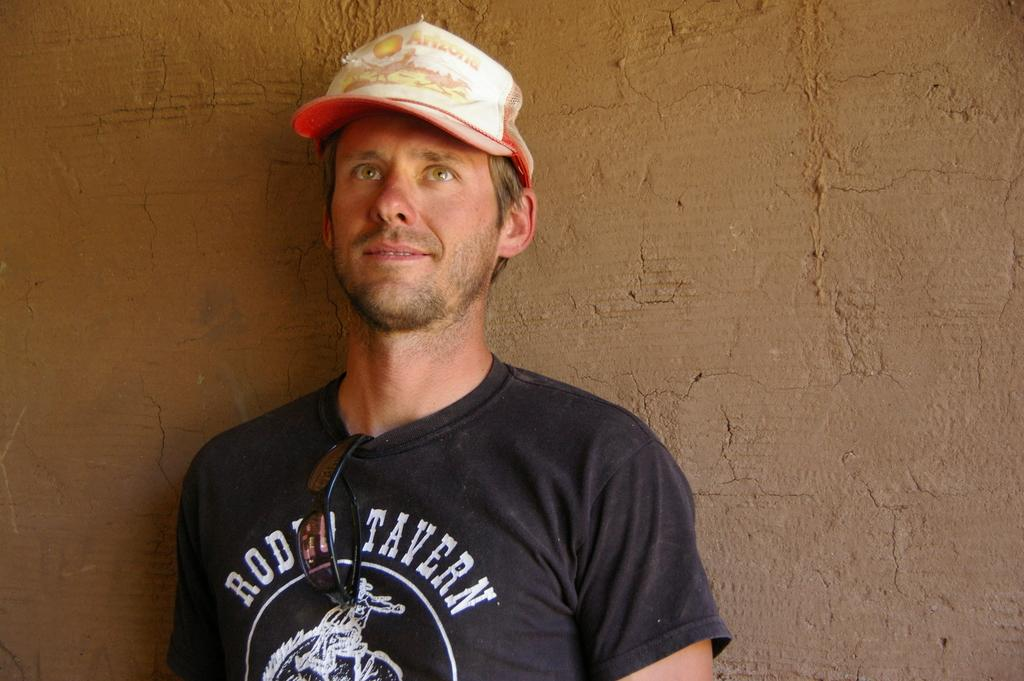<image>
Write a terse but informative summary of the picture. A guy wears a hat with the word Arizona on it. 